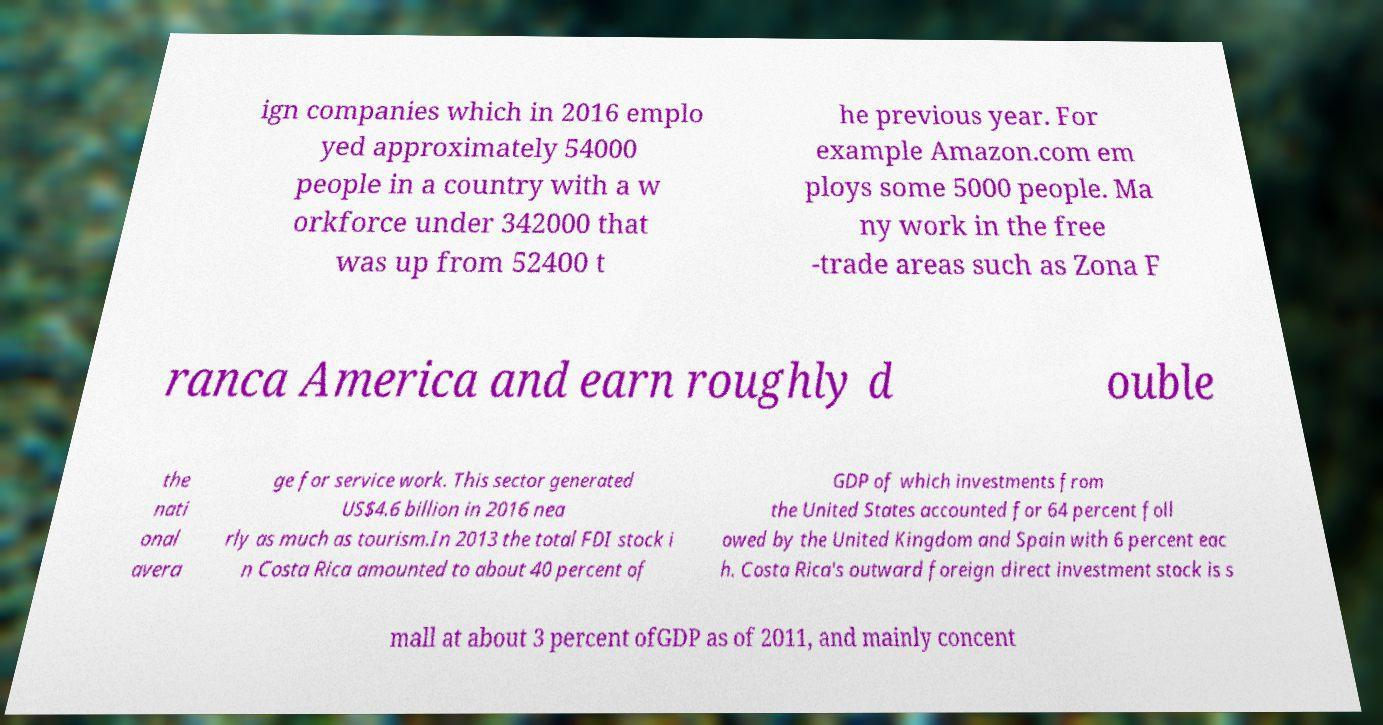There's text embedded in this image that I need extracted. Can you transcribe it verbatim? ign companies which in 2016 emplo yed approximately 54000 people in a country with a w orkforce under 342000 that was up from 52400 t he previous year. For example Amazon.com em ploys some 5000 people. Ma ny work in the free -trade areas such as Zona F ranca America and earn roughly d ouble the nati onal avera ge for service work. This sector generated US$4.6 billion in 2016 nea rly as much as tourism.In 2013 the total FDI stock i n Costa Rica amounted to about 40 percent of GDP of which investments from the United States accounted for 64 percent foll owed by the United Kingdom and Spain with 6 percent eac h. Costa Rica's outward foreign direct investment stock is s mall at about 3 percent ofGDP as of 2011, and mainly concent 